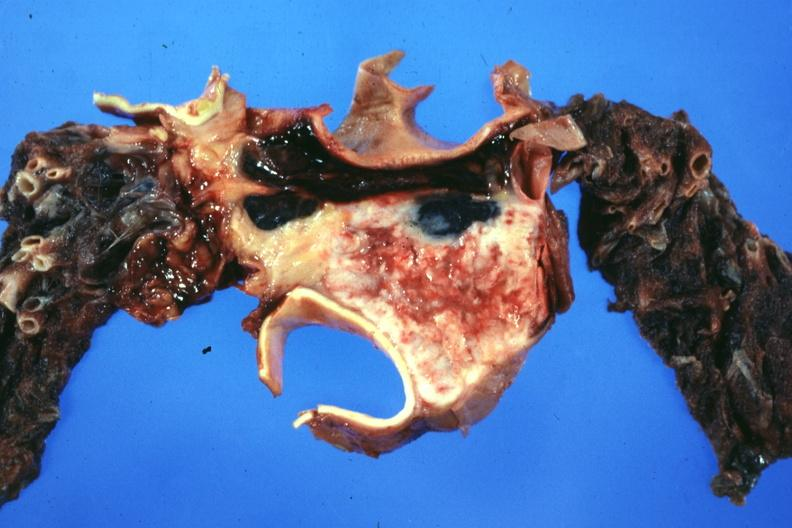s thymus present?
Answer the question using a single word or phrase. Yes 